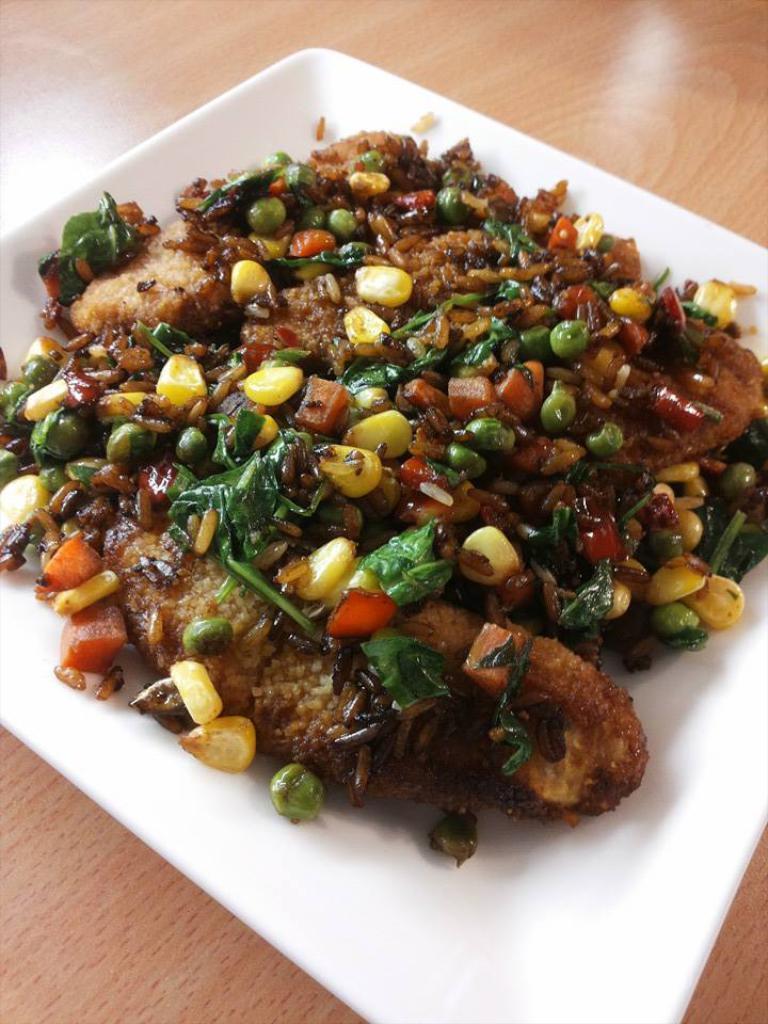How would you summarize this image in a sentence or two? In the image there is some cooked food item is served in a white plate and it is garnished with some peas,corn,carrots and some other veggies. 